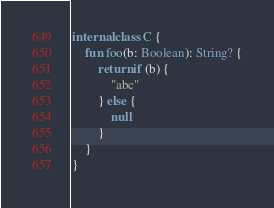<code> <loc_0><loc_0><loc_500><loc_500><_Kotlin_>internal class C {
    fun foo(b: Boolean): String? {
        return if (b) {
            "abc"
        } else {
            null
        }
    }
}</code> 